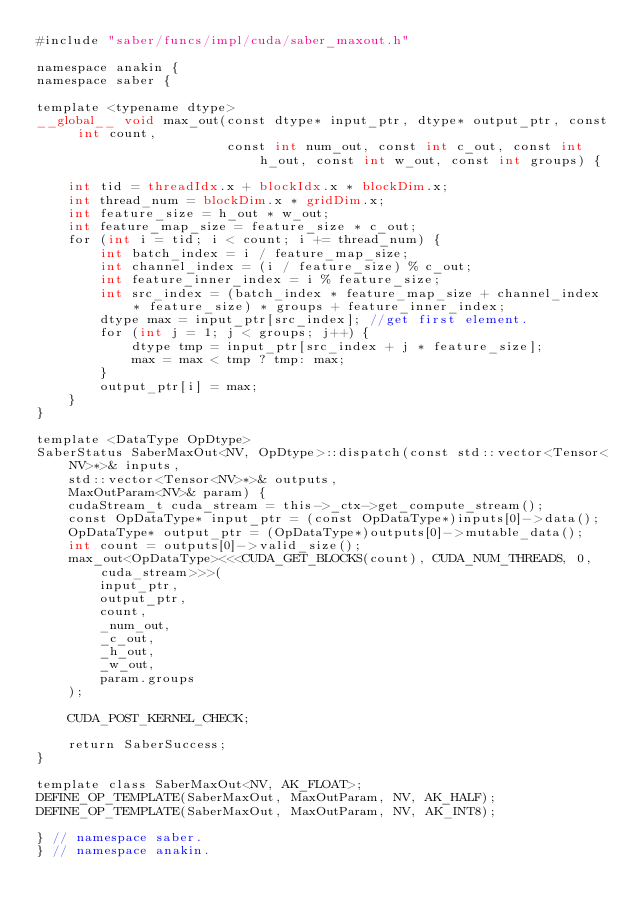<code> <loc_0><loc_0><loc_500><loc_500><_Cuda_>#include "saber/funcs/impl/cuda/saber_maxout.h"

namespace anakin {
namespace saber {

template <typename dtype>
__global__ void max_out(const dtype* input_ptr, dtype* output_ptr, const int count, 
                        const int num_out, const int c_out, const int h_out, const int w_out, const int groups) {
    
    int tid = threadIdx.x + blockIdx.x * blockDim.x;
    int thread_num = blockDim.x * gridDim.x;
    int feature_size = h_out * w_out;
    int feature_map_size = feature_size * c_out;
    for (int i = tid; i < count; i += thread_num) {
        int batch_index = i / feature_map_size;
        int channel_index = (i / feature_size) % c_out;
        int feature_inner_index = i % feature_size;
        int src_index = (batch_index * feature_map_size + channel_index * feature_size) * groups + feature_inner_index;
        dtype max = input_ptr[src_index]; //get first element.
        for (int j = 1; j < groups; j++) {
            dtype tmp = input_ptr[src_index + j * feature_size];
            max = max < tmp ? tmp: max;
        }
        output_ptr[i] = max;
    }
}

template <DataType OpDtype>
SaberStatus SaberMaxOut<NV, OpDtype>::dispatch(const std::vector<Tensor<NV>*>& inputs,
    std::vector<Tensor<NV>*>& outputs,
    MaxOutParam<NV>& param) {
    cudaStream_t cuda_stream = this->_ctx->get_compute_stream();
    const OpDataType* input_ptr = (const OpDataType*)inputs[0]->data();
    OpDataType* output_ptr = (OpDataType*)outputs[0]->mutable_data();
    int count = outputs[0]->valid_size();
    max_out<OpDataType><<<CUDA_GET_BLOCKS(count), CUDA_NUM_THREADS, 0, cuda_stream>>>(
        input_ptr,
        output_ptr,
        count,
        _num_out,
        _c_out,
        _h_out,
        _w_out,
        param.groups    
    );

    CUDA_POST_KERNEL_CHECK;

    return SaberSuccess;
}

template class SaberMaxOut<NV, AK_FLOAT>;
DEFINE_OP_TEMPLATE(SaberMaxOut, MaxOutParam, NV, AK_HALF);
DEFINE_OP_TEMPLATE(SaberMaxOut, MaxOutParam, NV, AK_INT8);

} // namespace saber.
} // namespace anakin.</code> 